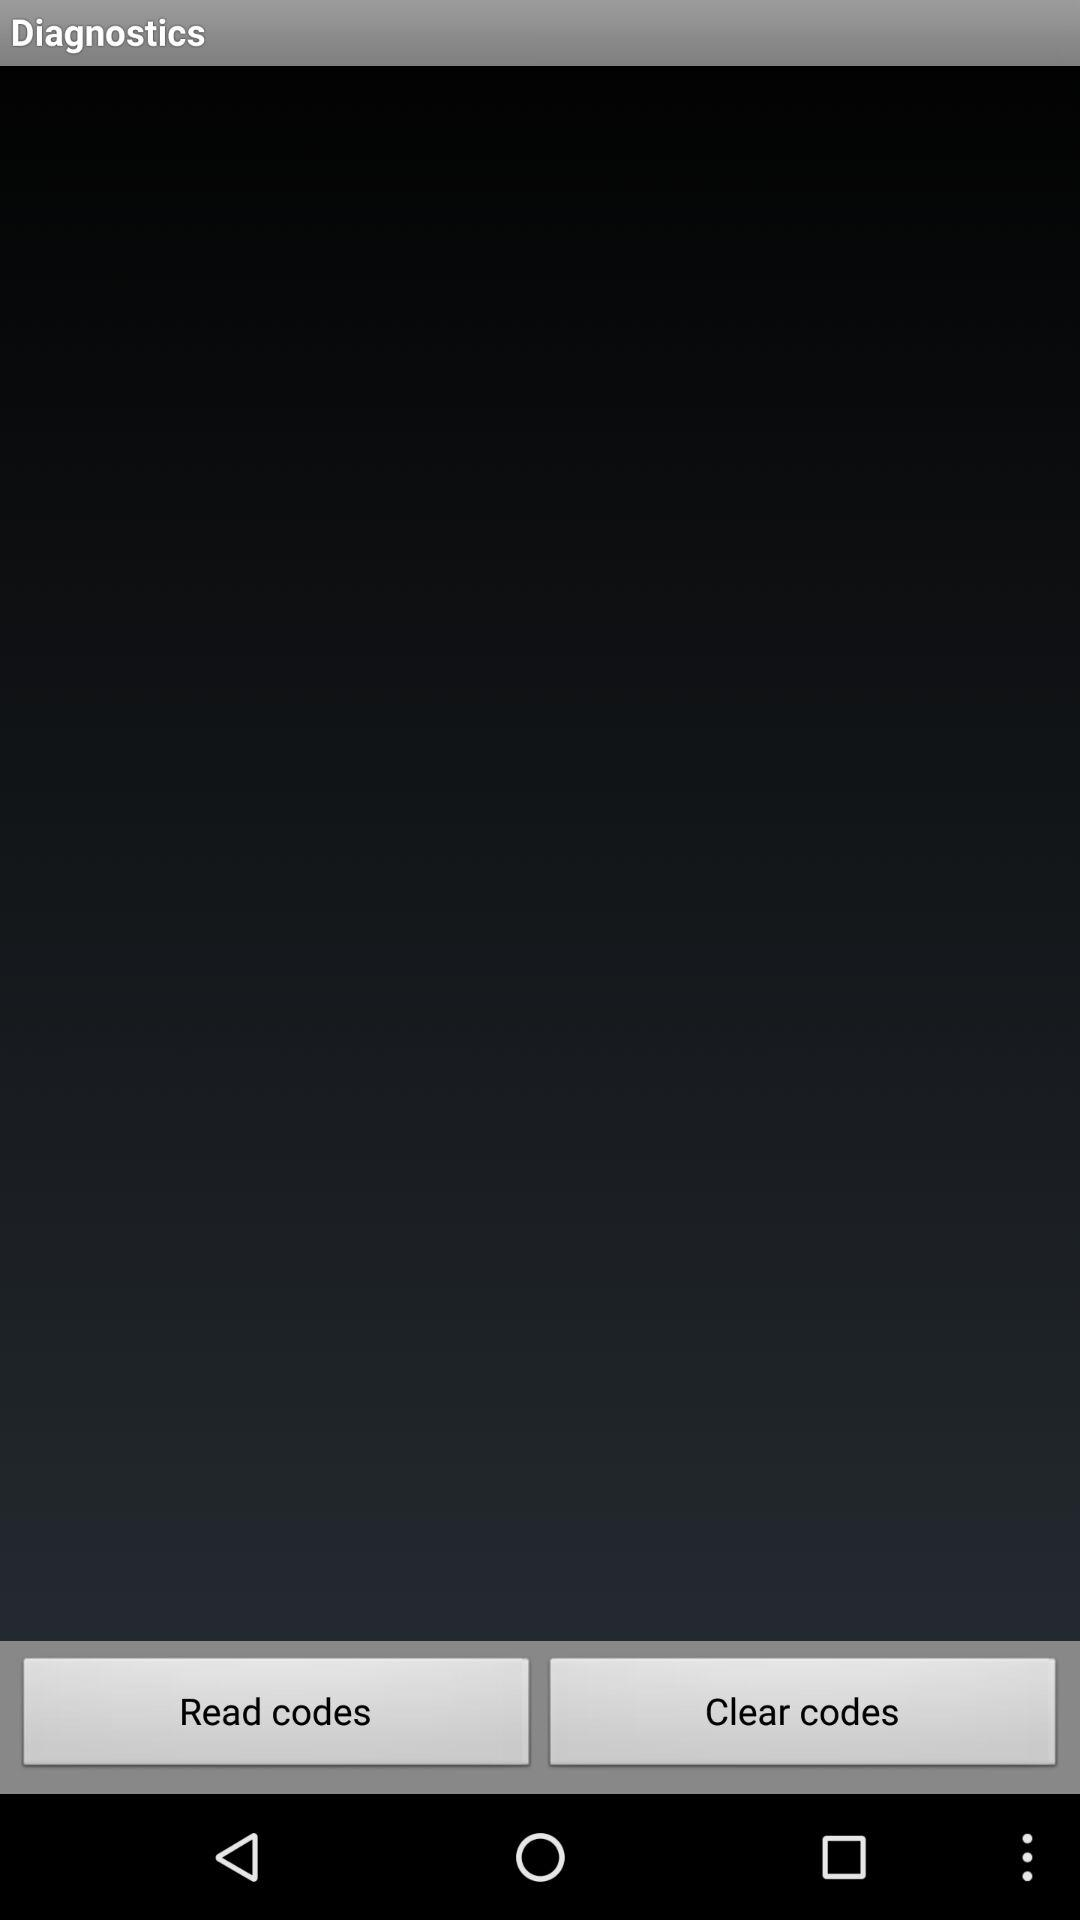What is the app name? The app name is "Diagnostics". 